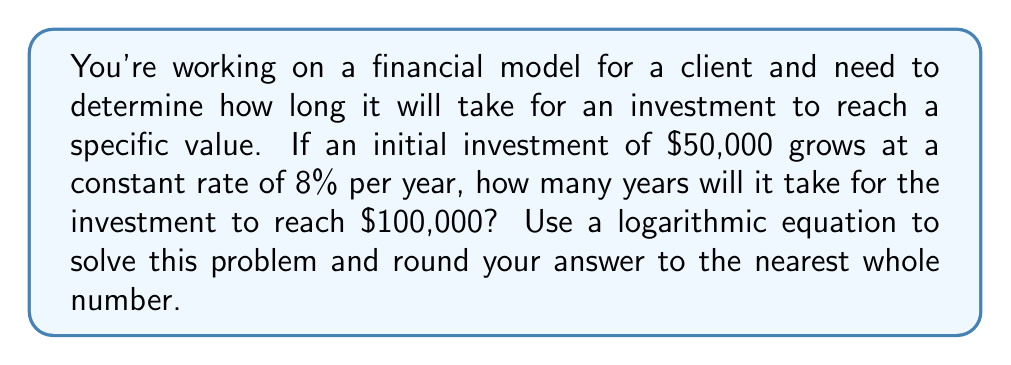Provide a solution to this math problem. Let's approach this step-by-step using the compound interest formula and logarithms:

1) The compound interest formula is:
   $A = P(1 + r)^t$
   Where:
   $A$ = final amount
   $P$ = principal (initial investment)
   $r$ = annual interest rate (as a decimal)
   $t$ = time in years

2) We know:
   $A = 100,000$
   $P = 50,000$
   $r = 0.08$ (8% expressed as a decimal)
   We need to solve for $t$

3) Let's substitute these values into the formula:
   $100,000 = 50,000(1 + 0.08)^t$

4) Divide both sides by 50,000:
   $2 = (1.08)^t$

5) Now we can use logarithms to solve for $t$. Let's use natural log (ln):
   $\ln(2) = \ln((1.08)^t)$

6) Using the logarithm property $\ln(a^b) = b\ln(a)$:
   $\ln(2) = t\ln(1.08)$

7) Solve for $t$:
   $t = \frac{\ln(2)}{\ln(1.08)}$

8) Use a calculator to evaluate:
   $t \approx 9.006$ years

9) Rounding to the nearest whole number:
   $t = 9$ years
Answer: 9 years 